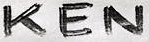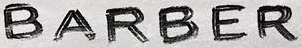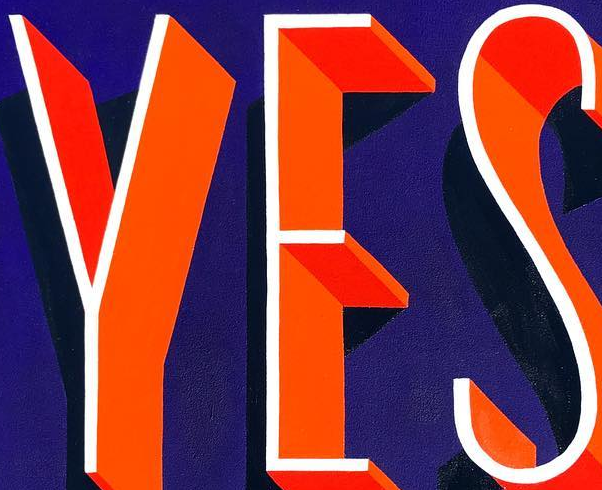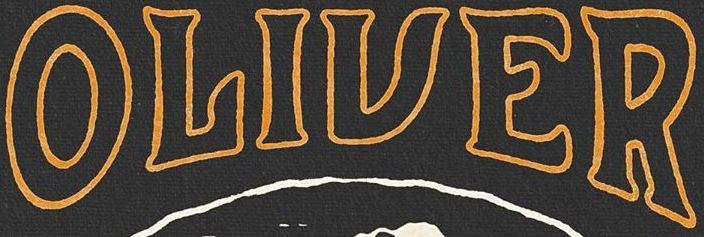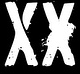What words are shown in these images in order, separated by a semicolon? KEN; BARBER; YES; OLIVER; XX 